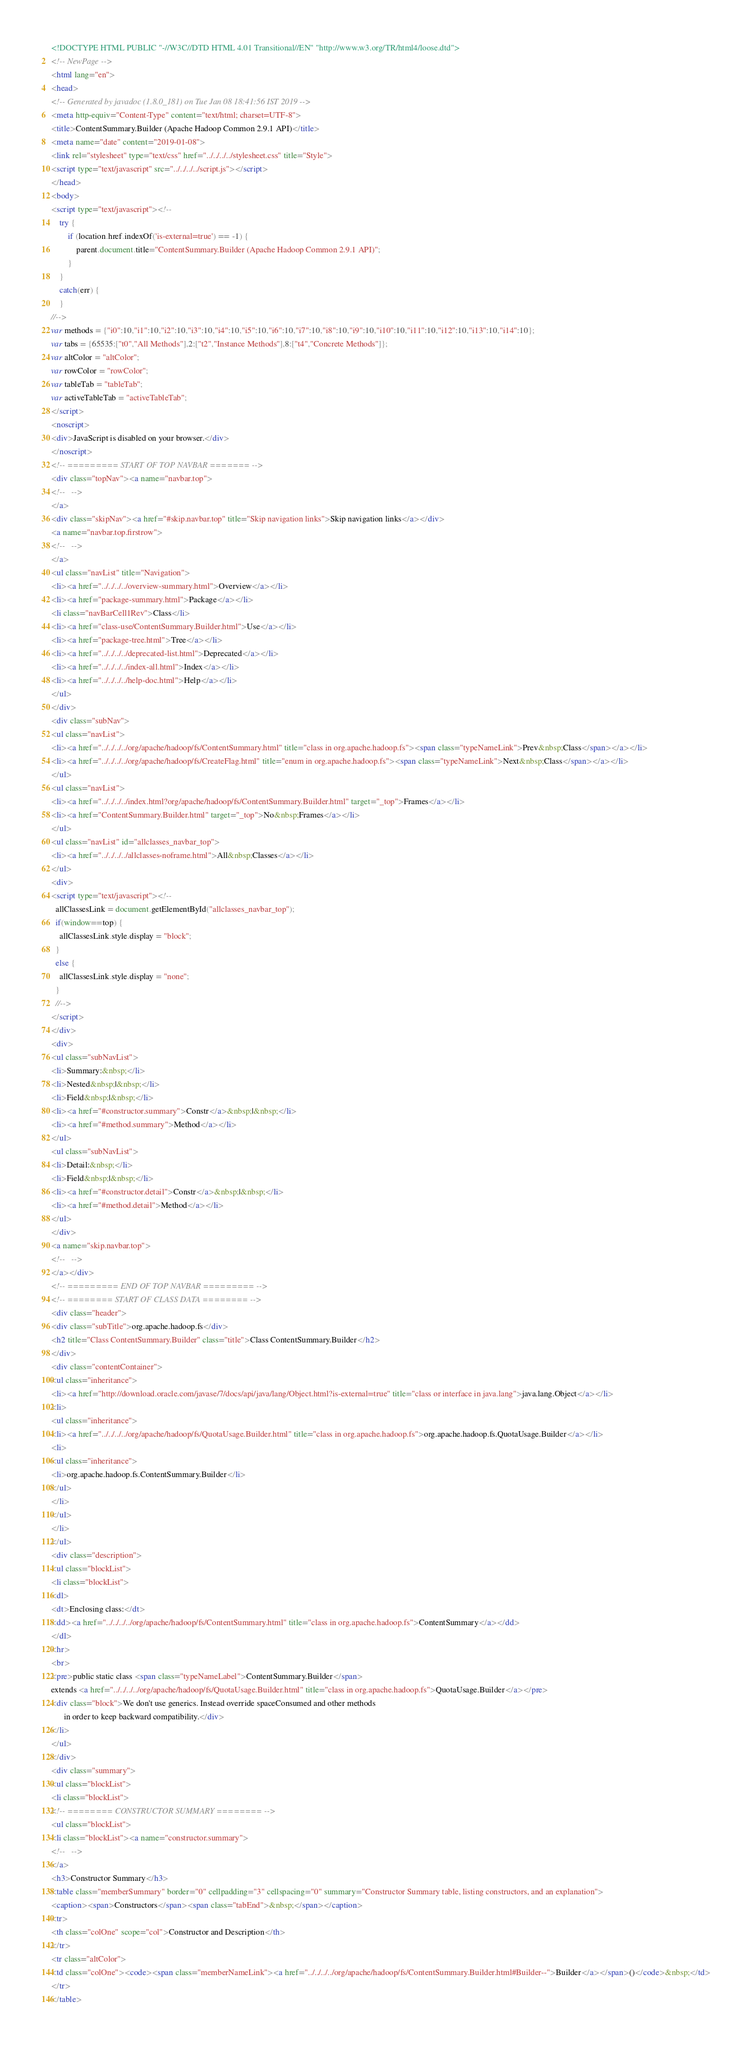Convert code to text. <code><loc_0><loc_0><loc_500><loc_500><_HTML_><!DOCTYPE HTML PUBLIC "-//W3C//DTD HTML 4.01 Transitional//EN" "http://www.w3.org/TR/html4/loose.dtd">
<!-- NewPage -->
<html lang="en">
<head>
<!-- Generated by javadoc (1.8.0_181) on Tue Jan 08 18:41:56 IST 2019 -->
<meta http-equiv="Content-Type" content="text/html; charset=UTF-8">
<title>ContentSummary.Builder (Apache Hadoop Common 2.9.1 API)</title>
<meta name="date" content="2019-01-08">
<link rel="stylesheet" type="text/css" href="../../../../stylesheet.css" title="Style">
<script type="text/javascript" src="../../../../script.js"></script>
</head>
<body>
<script type="text/javascript"><!--
    try {
        if (location.href.indexOf('is-external=true') == -1) {
            parent.document.title="ContentSummary.Builder (Apache Hadoop Common 2.9.1 API)";
        }
    }
    catch(err) {
    }
//-->
var methods = {"i0":10,"i1":10,"i2":10,"i3":10,"i4":10,"i5":10,"i6":10,"i7":10,"i8":10,"i9":10,"i10":10,"i11":10,"i12":10,"i13":10,"i14":10};
var tabs = {65535:["t0","All Methods"],2:["t2","Instance Methods"],8:["t4","Concrete Methods"]};
var altColor = "altColor";
var rowColor = "rowColor";
var tableTab = "tableTab";
var activeTableTab = "activeTableTab";
</script>
<noscript>
<div>JavaScript is disabled on your browser.</div>
</noscript>
<!-- ========= START OF TOP NAVBAR ======= -->
<div class="topNav"><a name="navbar.top">
<!--   -->
</a>
<div class="skipNav"><a href="#skip.navbar.top" title="Skip navigation links">Skip navigation links</a></div>
<a name="navbar.top.firstrow">
<!--   -->
</a>
<ul class="navList" title="Navigation">
<li><a href="../../../../overview-summary.html">Overview</a></li>
<li><a href="package-summary.html">Package</a></li>
<li class="navBarCell1Rev">Class</li>
<li><a href="class-use/ContentSummary.Builder.html">Use</a></li>
<li><a href="package-tree.html">Tree</a></li>
<li><a href="../../../../deprecated-list.html">Deprecated</a></li>
<li><a href="../../../../index-all.html">Index</a></li>
<li><a href="../../../../help-doc.html">Help</a></li>
</ul>
</div>
<div class="subNav">
<ul class="navList">
<li><a href="../../../../org/apache/hadoop/fs/ContentSummary.html" title="class in org.apache.hadoop.fs"><span class="typeNameLink">Prev&nbsp;Class</span></a></li>
<li><a href="../../../../org/apache/hadoop/fs/CreateFlag.html" title="enum in org.apache.hadoop.fs"><span class="typeNameLink">Next&nbsp;Class</span></a></li>
</ul>
<ul class="navList">
<li><a href="../../../../index.html?org/apache/hadoop/fs/ContentSummary.Builder.html" target="_top">Frames</a></li>
<li><a href="ContentSummary.Builder.html" target="_top">No&nbsp;Frames</a></li>
</ul>
<ul class="navList" id="allclasses_navbar_top">
<li><a href="../../../../allclasses-noframe.html">All&nbsp;Classes</a></li>
</ul>
<div>
<script type="text/javascript"><!--
  allClassesLink = document.getElementById("allclasses_navbar_top");
  if(window==top) {
    allClassesLink.style.display = "block";
  }
  else {
    allClassesLink.style.display = "none";
  }
  //-->
</script>
</div>
<div>
<ul class="subNavList">
<li>Summary:&nbsp;</li>
<li>Nested&nbsp;|&nbsp;</li>
<li>Field&nbsp;|&nbsp;</li>
<li><a href="#constructor.summary">Constr</a>&nbsp;|&nbsp;</li>
<li><a href="#method.summary">Method</a></li>
</ul>
<ul class="subNavList">
<li>Detail:&nbsp;</li>
<li>Field&nbsp;|&nbsp;</li>
<li><a href="#constructor.detail">Constr</a>&nbsp;|&nbsp;</li>
<li><a href="#method.detail">Method</a></li>
</ul>
</div>
<a name="skip.navbar.top">
<!--   -->
</a></div>
<!-- ========= END OF TOP NAVBAR ========= -->
<!-- ======== START OF CLASS DATA ======== -->
<div class="header">
<div class="subTitle">org.apache.hadoop.fs</div>
<h2 title="Class ContentSummary.Builder" class="title">Class ContentSummary.Builder</h2>
</div>
<div class="contentContainer">
<ul class="inheritance">
<li><a href="http://download.oracle.com/javase/7/docs/api/java/lang/Object.html?is-external=true" title="class or interface in java.lang">java.lang.Object</a></li>
<li>
<ul class="inheritance">
<li><a href="../../../../org/apache/hadoop/fs/QuotaUsage.Builder.html" title="class in org.apache.hadoop.fs">org.apache.hadoop.fs.QuotaUsage.Builder</a></li>
<li>
<ul class="inheritance">
<li>org.apache.hadoop.fs.ContentSummary.Builder</li>
</ul>
</li>
</ul>
</li>
</ul>
<div class="description">
<ul class="blockList">
<li class="blockList">
<dl>
<dt>Enclosing class:</dt>
<dd><a href="../../../../org/apache/hadoop/fs/ContentSummary.html" title="class in org.apache.hadoop.fs">ContentSummary</a></dd>
</dl>
<hr>
<br>
<pre>public static class <span class="typeNameLabel">ContentSummary.Builder</span>
extends <a href="../../../../org/apache/hadoop/fs/QuotaUsage.Builder.html" title="class in org.apache.hadoop.fs">QuotaUsage.Builder</a></pre>
<div class="block">We don't use generics. Instead override spaceConsumed and other methods
      in order to keep backward compatibility.</div>
</li>
</ul>
</div>
<div class="summary">
<ul class="blockList">
<li class="blockList">
<!-- ======== CONSTRUCTOR SUMMARY ======== -->
<ul class="blockList">
<li class="blockList"><a name="constructor.summary">
<!--   -->
</a>
<h3>Constructor Summary</h3>
<table class="memberSummary" border="0" cellpadding="3" cellspacing="0" summary="Constructor Summary table, listing constructors, and an explanation">
<caption><span>Constructors</span><span class="tabEnd">&nbsp;</span></caption>
<tr>
<th class="colOne" scope="col">Constructor and Description</th>
</tr>
<tr class="altColor">
<td class="colOne"><code><span class="memberNameLink"><a href="../../../../org/apache/hadoop/fs/ContentSummary.Builder.html#Builder--">Builder</a></span>()</code>&nbsp;</td>
</tr>
</table></code> 